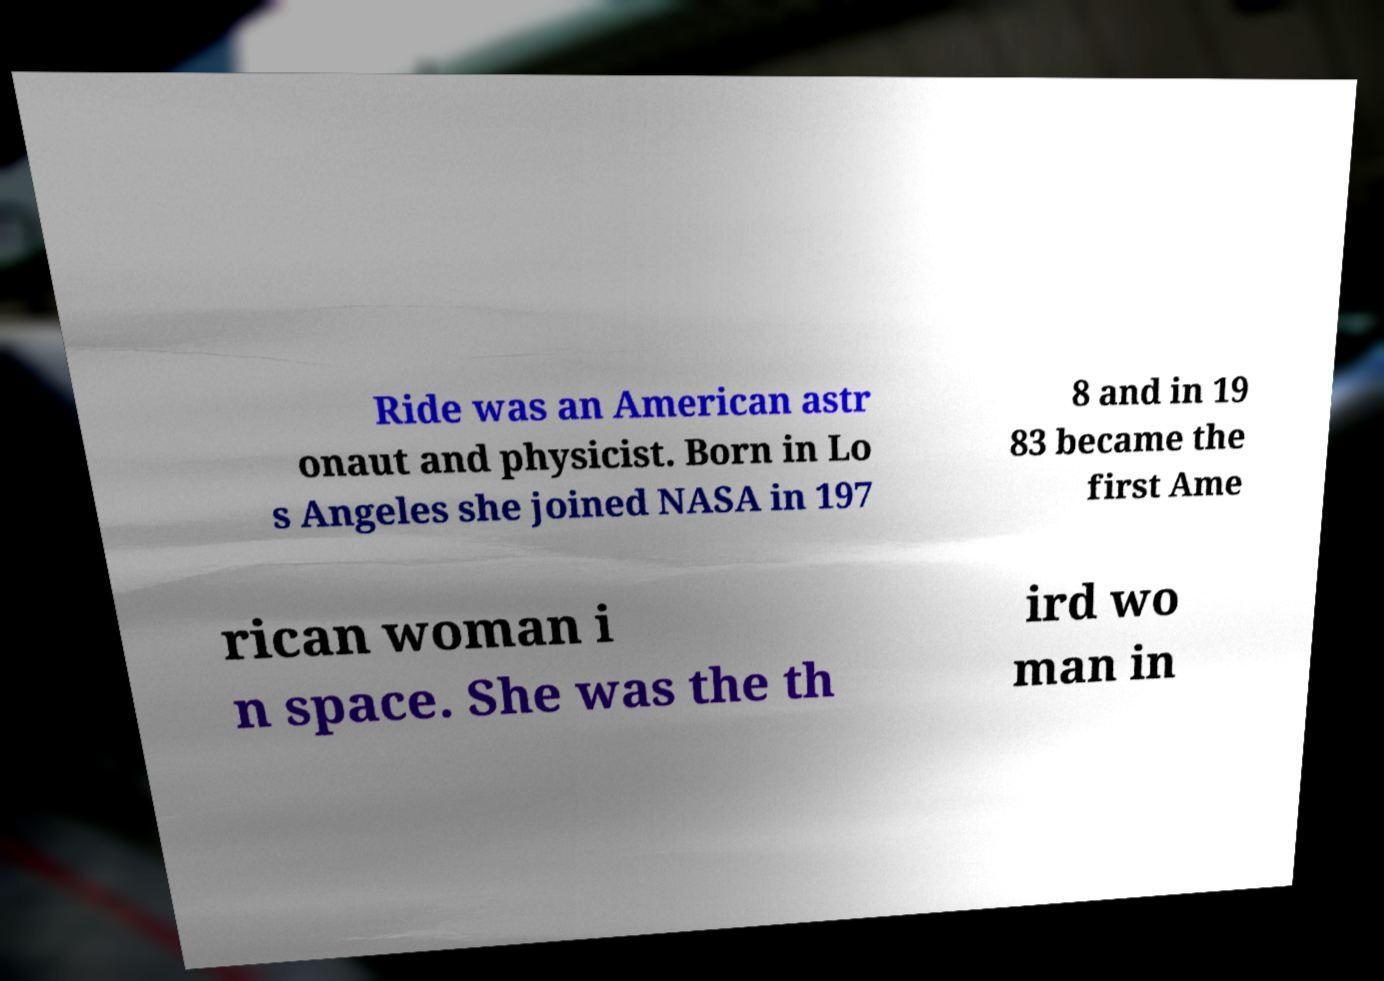I need the written content from this picture converted into text. Can you do that? Ride was an American astr onaut and physicist. Born in Lo s Angeles she joined NASA in 197 8 and in 19 83 became the first Ame rican woman i n space. She was the th ird wo man in 